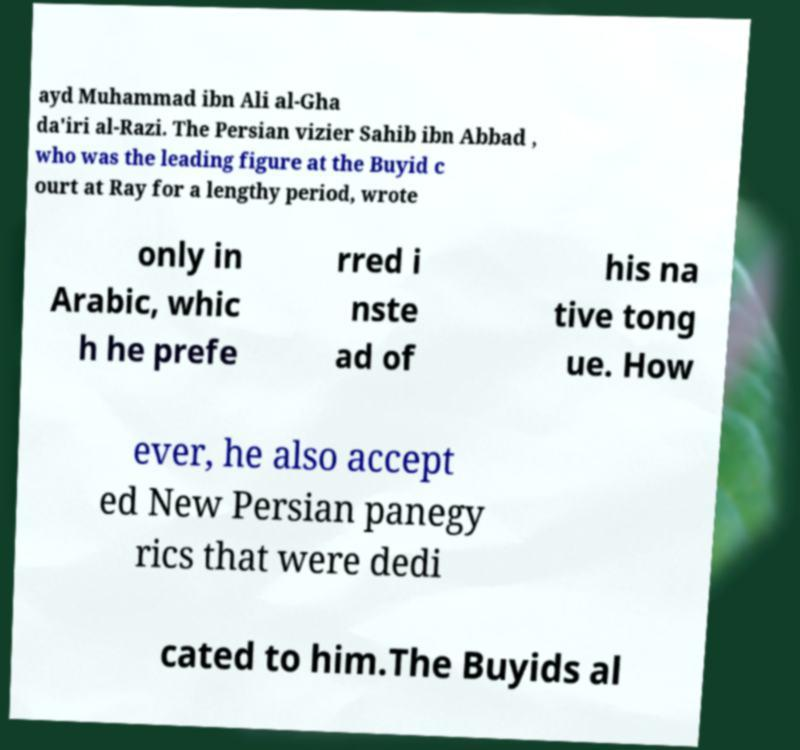Could you assist in decoding the text presented in this image and type it out clearly? ayd Muhammad ibn Ali al-Gha da'iri al-Razi. The Persian vizier Sahib ibn Abbad , who was the leading figure at the Buyid c ourt at Ray for a lengthy period, wrote only in Arabic, whic h he prefe rred i nste ad of his na tive tong ue. How ever, he also accept ed New Persian panegy rics that were dedi cated to him.The Buyids al 